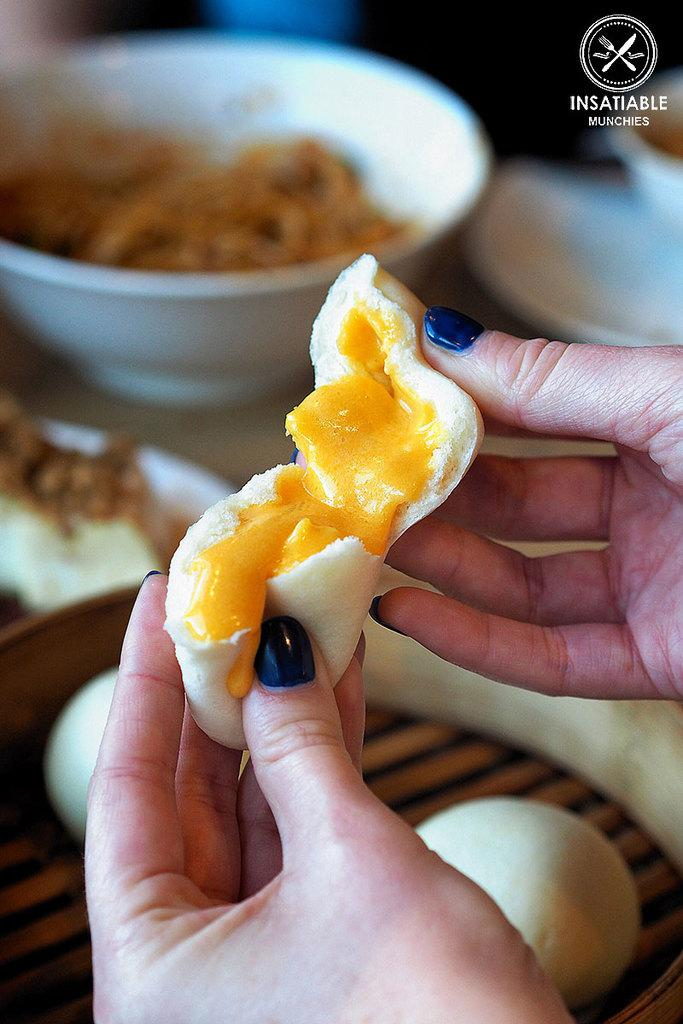What is the person in the image holding? There is food in the hand of a person in the image. Can you describe the food that is visible in the background? Unfortunately, the provided facts do not give any information about the food visible in the background. What is the structure of the plot in the image? There is no plot present in the image, as it is a still photograph and not a narrative. 